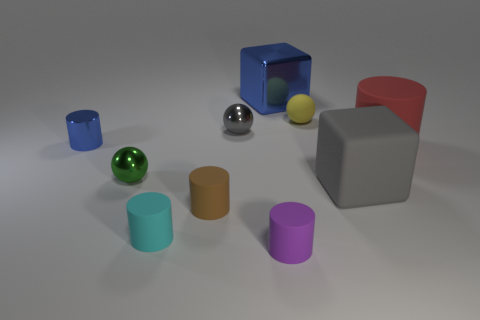Subtract all cyan cylinders. How many cylinders are left? 4 Subtract all small brown cylinders. How many cylinders are left? 4 Subtract all blue cylinders. Subtract all green cubes. How many cylinders are left? 4 Subtract all cubes. How many objects are left? 8 Add 9 matte blocks. How many matte blocks are left? 10 Add 5 cyan rubber objects. How many cyan rubber objects exist? 6 Subtract 0 cyan spheres. How many objects are left? 10 Subtract all big red matte cylinders. Subtract all tiny yellow objects. How many objects are left? 8 